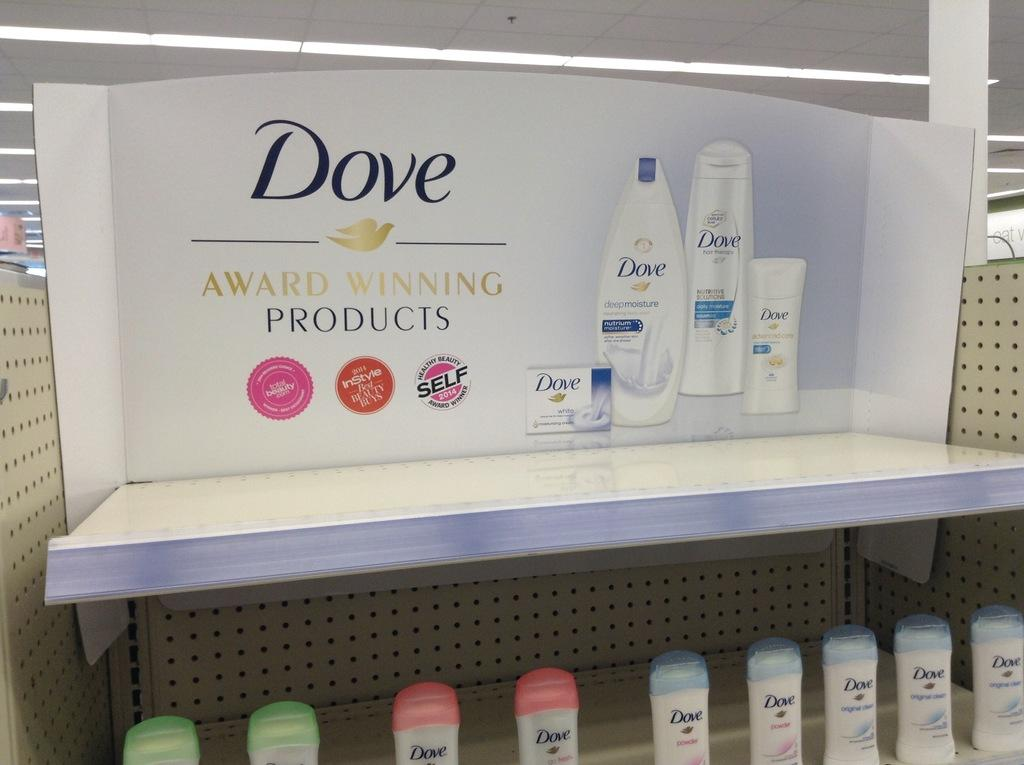<image>
Create a compact narrative representing the image presented. Store display case of Dove soap products on a shelf. 